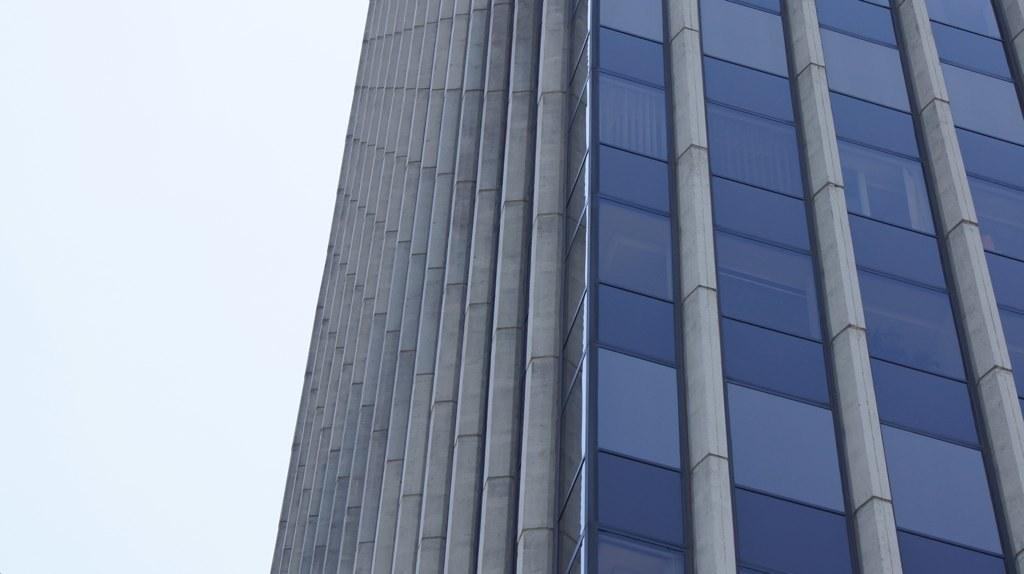What type of structure is the main subject of the picture? There is a tower building in the picture. What specific feature can be observed on the tower building? The tower building has glass elements. What can be seen in the background of the picture? The sky is visible in the picture. Where is the rock located in the picture? There is no rock present in the picture; it features a tower building with glass elements and a visible sky. What type of cap is on top of the tower building? There is no cap on top of the tower building in the picture. 